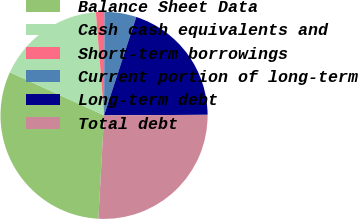Convert chart to OTSL. <chart><loc_0><loc_0><loc_500><loc_500><pie_chart><fcel>Balance Sheet Data<fcel>Cash cash equivalents and<fcel>Short-term borrowings<fcel>Current portion of long-term<fcel>Long-term debt<fcel>Total debt<nl><fcel>30.97%<fcel>16.91%<fcel>1.32%<fcel>4.98%<fcel>19.87%<fcel>25.96%<nl></chart> 